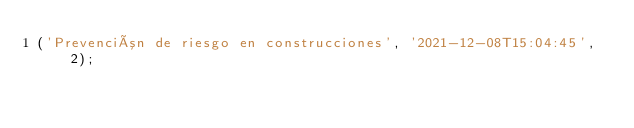Convert code to text. <code><loc_0><loc_0><loc_500><loc_500><_SQL_>('Prevención de riesgo en construcciones', '2021-12-08T15:04:45', 2);

</code> 